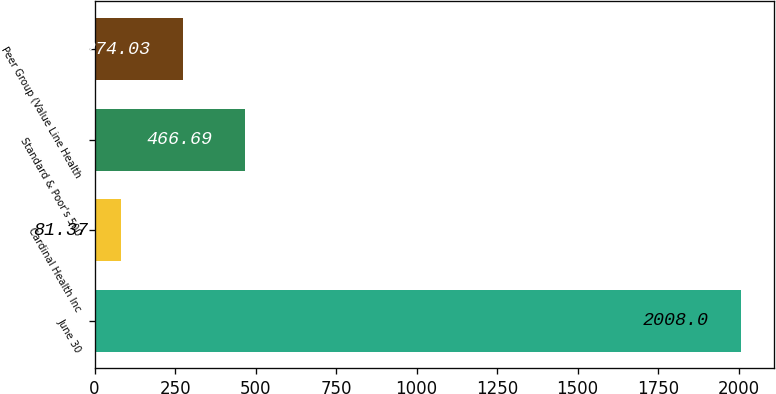Convert chart to OTSL. <chart><loc_0><loc_0><loc_500><loc_500><bar_chart><fcel>June 30<fcel>Cardinal Health Inc<fcel>Standard & Poor's 500<fcel>Peer Group (Value Line Health<nl><fcel>2008<fcel>81.37<fcel>466.69<fcel>274.03<nl></chart> 